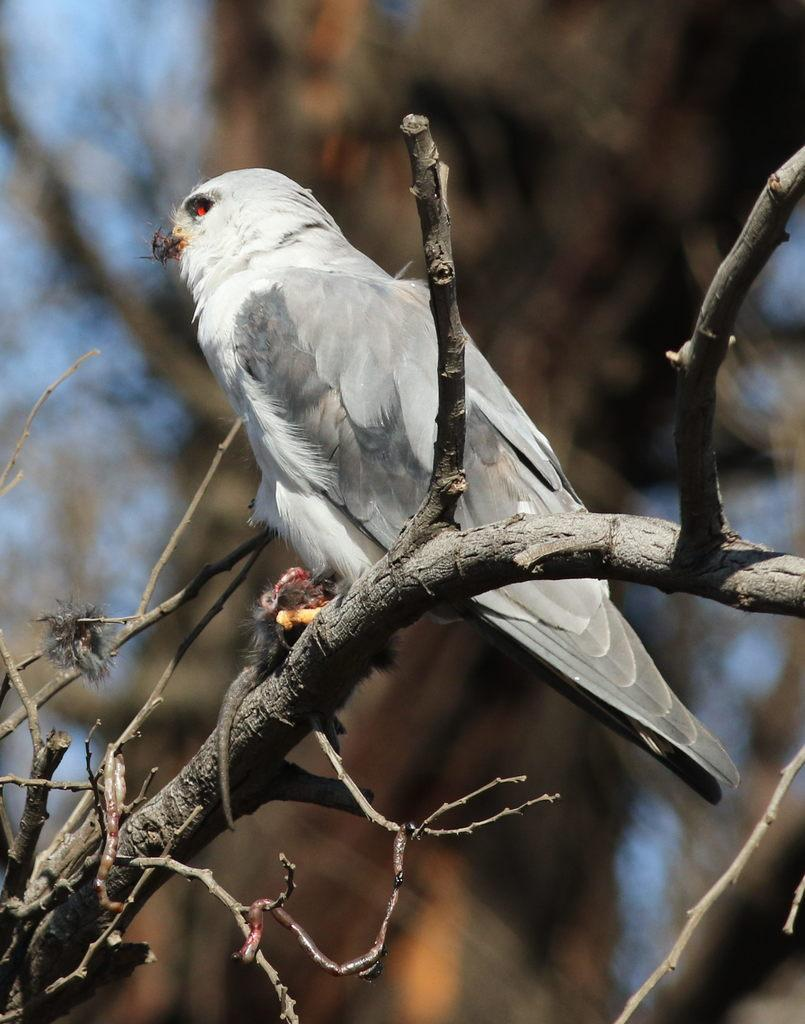What type of animal can be seen in the image? There is a bird in the image. Where is the bird located? The bird is on the branch of a tree. Can you describe the background of the image? The background of the image is blurred. What type of food is the bird eating in the image? There is no food visible in the image, and the bird's actions are not described. 